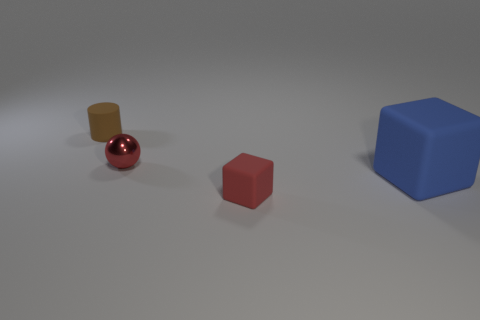Does the small brown cylinder have the same material as the tiny sphere?
Your answer should be very brief. No. How many objects are either tiny matte things left of the tiny red metal ball or tiny purple matte cylinders?
Your answer should be compact. 1. What number of other objects are there of the same size as the sphere?
Ensure brevity in your answer.  2. Are there an equal number of matte cylinders that are in front of the big blue matte cube and tiny spheres on the left side of the brown matte cylinder?
Provide a succinct answer. Yes. There is a large object that is the same shape as the tiny red matte thing; what is its color?
Your answer should be compact. Blue. Is there any other thing that has the same shape as the red metal thing?
Keep it short and to the point. No. Does the big rubber block that is in front of the tiny shiny thing have the same color as the tiny shiny thing?
Provide a short and direct response. No. What is the size of the blue rubber object that is the same shape as the red matte object?
Offer a very short reply. Large. What number of red cubes are made of the same material as the large blue cube?
Offer a terse response. 1. There is a rubber block that is in front of the blue cube in front of the tiny red shiny sphere; are there any small cubes that are on the left side of it?
Ensure brevity in your answer.  No. 